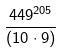Convert formula to latex. <formula><loc_0><loc_0><loc_500><loc_500>\frac { 4 4 9 ^ { 2 0 5 } } { ( 1 0 \cdot 9 ) }</formula> 